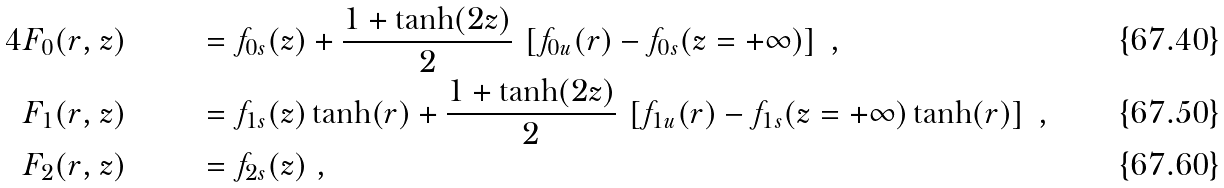Convert formula to latex. <formula><loc_0><loc_0><loc_500><loc_500>4 & F _ { 0 } ( r , z ) & & = f _ { 0 s } ( z ) + \frac { 1 + \tanh ( 2 z ) } 2 \, \left [ f _ { 0 u } ( r ) - f _ { 0 s } ( z = + \infty ) \right ] \ , \\ & F _ { 1 } ( r , z ) & & = f _ { 1 s } ( z ) \tanh ( r ) + \frac { 1 + \tanh ( 2 z ) } 2 \, \left [ f _ { 1 u } ( r ) - f _ { 1 s } ( z = + \infty ) \tanh ( r ) \right ] \ , \\ & F _ { 2 } ( r , z ) & & = f _ { 2 s } ( z ) \ ,</formula> 